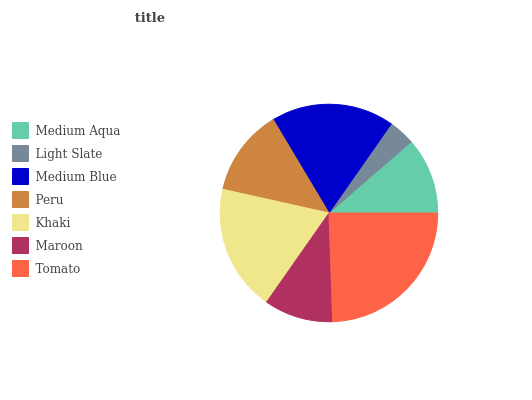Is Light Slate the minimum?
Answer yes or no. Yes. Is Tomato the maximum?
Answer yes or no. Yes. Is Medium Blue the minimum?
Answer yes or no. No. Is Medium Blue the maximum?
Answer yes or no. No. Is Medium Blue greater than Light Slate?
Answer yes or no. Yes. Is Light Slate less than Medium Blue?
Answer yes or no. Yes. Is Light Slate greater than Medium Blue?
Answer yes or no. No. Is Medium Blue less than Light Slate?
Answer yes or no. No. Is Peru the high median?
Answer yes or no. Yes. Is Peru the low median?
Answer yes or no. Yes. Is Medium Aqua the high median?
Answer yes or no. No. Is Maroon the low median?
Answer yes or no. No. 